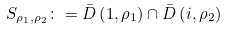Convert formula to latex. <formula><loc_0><loc_0><loc_500><loc_500>S _ { \rho _ { 1 } , \rho _ { 2 } } \colon = \bar { D } \left ( 1 , \rho _ { 1 } \right ) \cap \bar { D } \left ( i , \rho _ { 2 } \right )</formula> 